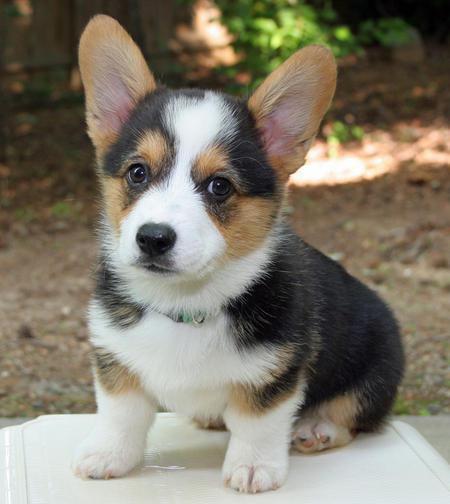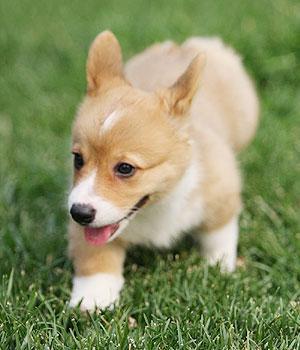The first image is the image on the left, the second image is the image on the right. For the images shown, is this caption "The dog in the left image is standing on all four legs with its body pointing left." true? Answer yes or no. No. The first image is the image on the left, the second image is the image on the right. Considering the images on both sides, is "The image on the right shows a corgi puppy in movement and the left one shows a corgi puppy sitting down." valid? Answer yes or no. Yes. 